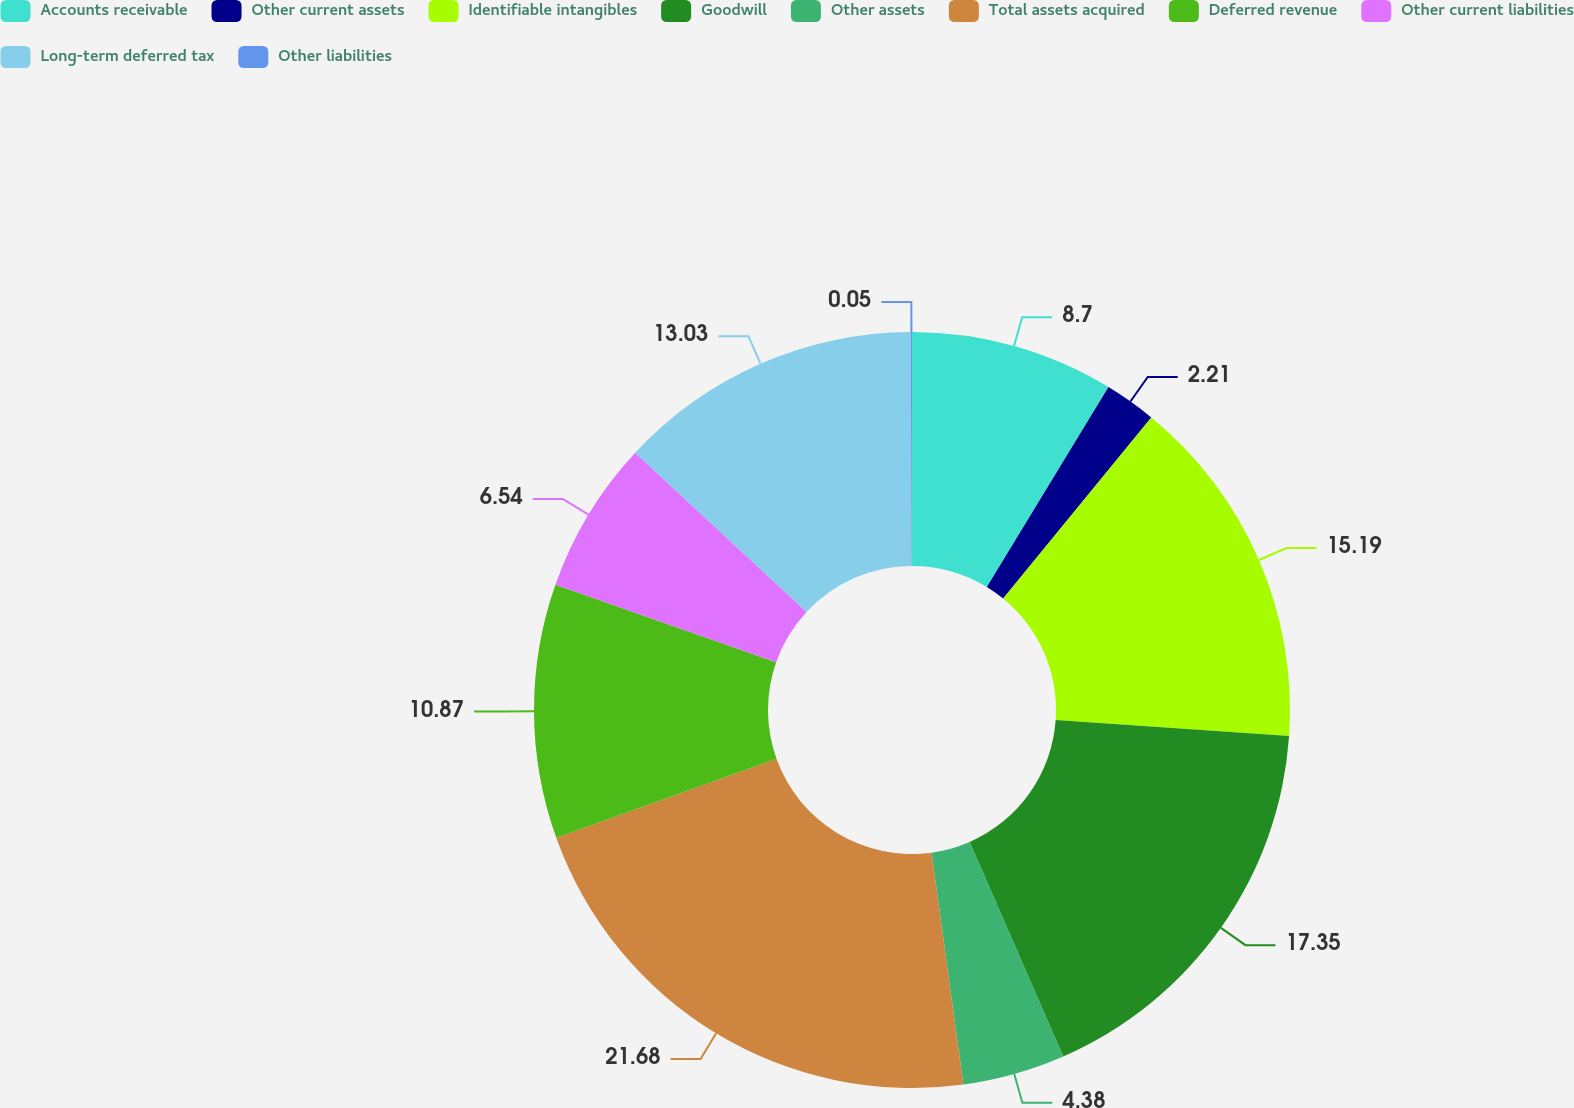Convert chart. <chart><loc_0><loc_0><loc_500><loc_500><pie_chart><fcel>Accounts receivable<fcel>Other current assets<fcel>Identifiable intangibles<fcel>Goodwill<fcel>Other assets<fcel>Total assets acquired<fcel>Deferred revenue<fcel>Other current liabilities<fcel>Long-term deferred tax<fcel>Other liabilities<nl><fcel>8.7%<fcel>2.21%<fcel>15.19%<fcel>17.35%<fcel>4.38%<fcel>21.68%<fcel>10.87%<fcel>6.54%<fcel>13.03%<fcel>0.05%<nl></chart> 